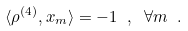<formula> <loc_0><loc_0><loc_500><loc_500>\langle \rho ^ { ( 4 ) } , x _ { m } \rangle = - 1 \ , \ \forall m \ .</formula> 